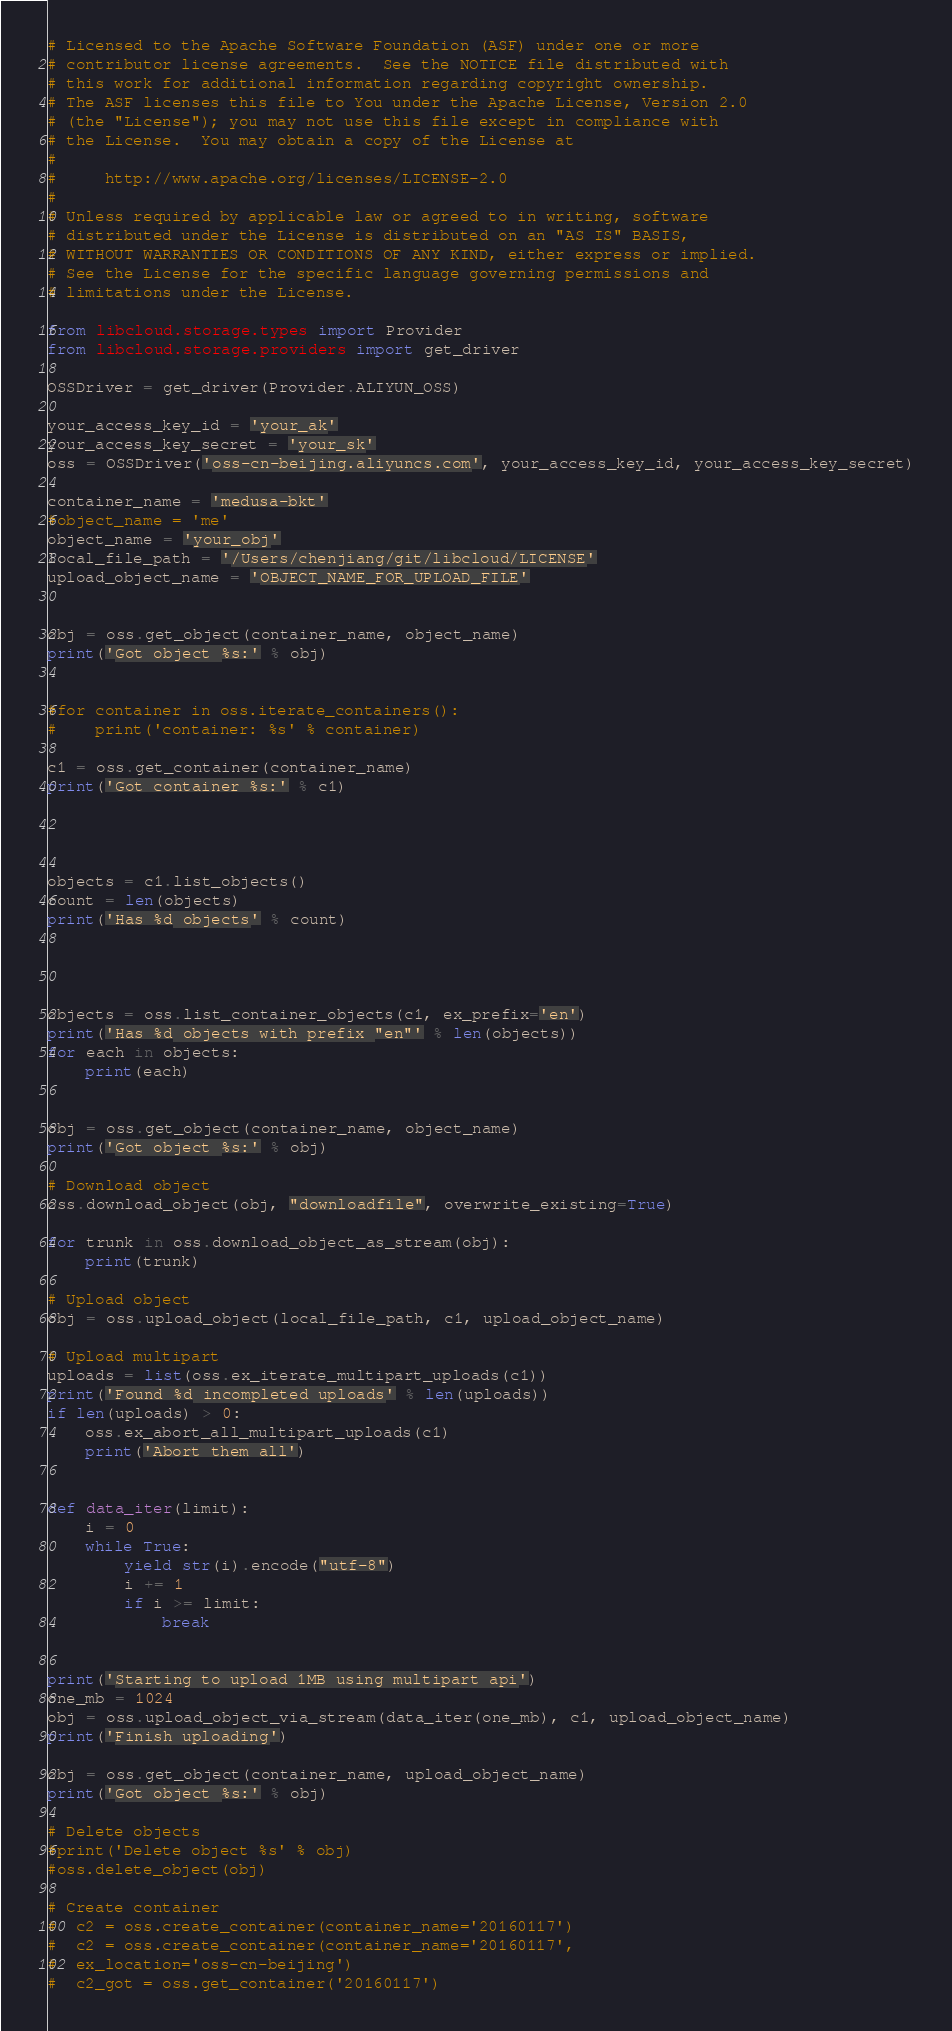<code> <loc_0><loc_0><loc_500><loc_500><_Python_># Licensed to the Apache Software Foundation (ASF) under one or more
# contributor license agreements.  See the NOTICE file distributed with
# this work for additional information regarding copyright ownership.
# The ASF licenses this file to You under the Apache License, Version 2.0
# (the "License"); you may not use this file except in compliance with
# the License.  You may obtain a copy of the License at
#
#     http://www.apache.org/licenses/LICENSE-2.0
#
# Unless required by applicable law or agreed to in writing, software
# distributed under the License is distributed on an "AS IS" BASIS,
# WITHOUT WARRANTIES OR CONDITIONS OF ANY KIND, either express or implied.
# See the License for the specific language governing permissions and
# limitations under the License.

from libcloud.storage.types import Provider
from libcloud.storage.providers import get_driver

OSSDriver = get_driver(Provider.ALIYUN_OSS)

your_access_key_id = 'your_ak'
your_access_key_secret = 'your_sk'
oss = OSSDriver('oss-cn-beijing.aliyuncs.com', your_access_key_id, your_access_key_secret)

container_name = 'medusa-bkt'
#object_name = 'me'
object_name = 'your_obj'
local_file_path = '/Users/chenjiang/git/libcloud/LICENSE'
upload_object_name = 'OBJECT_NAME_FOR_UPLOAD_FILE'


obj = oss.get_object(container_name, object_name)
print('Got object %s:' % obj)


#for container in oss.iterate_containers():
#    print('container: %s' % container)

c1 = oss.get_container(container_name)
print('Got container %s:' % c1)




objects = c1.list_objects()
count = len(objects)
print('Has %d objects' % count)




objects = oss.list_container_objects(c1, ex_prefix='en')
print('Has %d objects with prefix "en"' % len(objects))
for each in objects:
    print(each)


obj = oss.get_object(container_name, object_name)
print('Got object %s:' % obj)

# Download object
oss.download_object(obj, "downloadfile", overwrite_existing=True)

for trunk in oss.download_object_as_stream(obj):
    print(trunk)

# Upload object
obj = oss.upload_object(local_file_path, c1, upload_object_name)

# Upload multipart
uploads = list(oss.ex_iterate_multipart_uploads(c1))
print('Found %d incompleted uploads' % len(uploads))
if len(uploads) > 0:
    oss.ex_abort_all_multipart_uploads(c1)
    print('Abort them all')


def data_iter(limit):
    i = 0
    while True:
        yield str(i).encode("utf-8")
        i += 1
        if i >= limit:
            break


print('Starting to upload 1MB using multipart api')
one_mb = 1024
obj = oss.upload_object_via_stream(data_iter(one_mb), c1, upload_object_name)
print('Finish uploading')

obj = oss.get_object(container_name, upload_object_name)
print('Got object %s:' % obj)

# Delete objects
#print('Delete object %s' % obj)
#oss.delete_object(obj)

# Create container
#  c2 = oss.create_container(container_name='20160117')
#  c2 = oss.create_container(container_name='20160117',
#  ex_location='oss-cn-beijing')
#  c2_got = oss.get_container('20160117')
</code> 